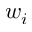<formula> <loc_0><loc_0><loc_500><loc_500>w _ { i }</formula> 